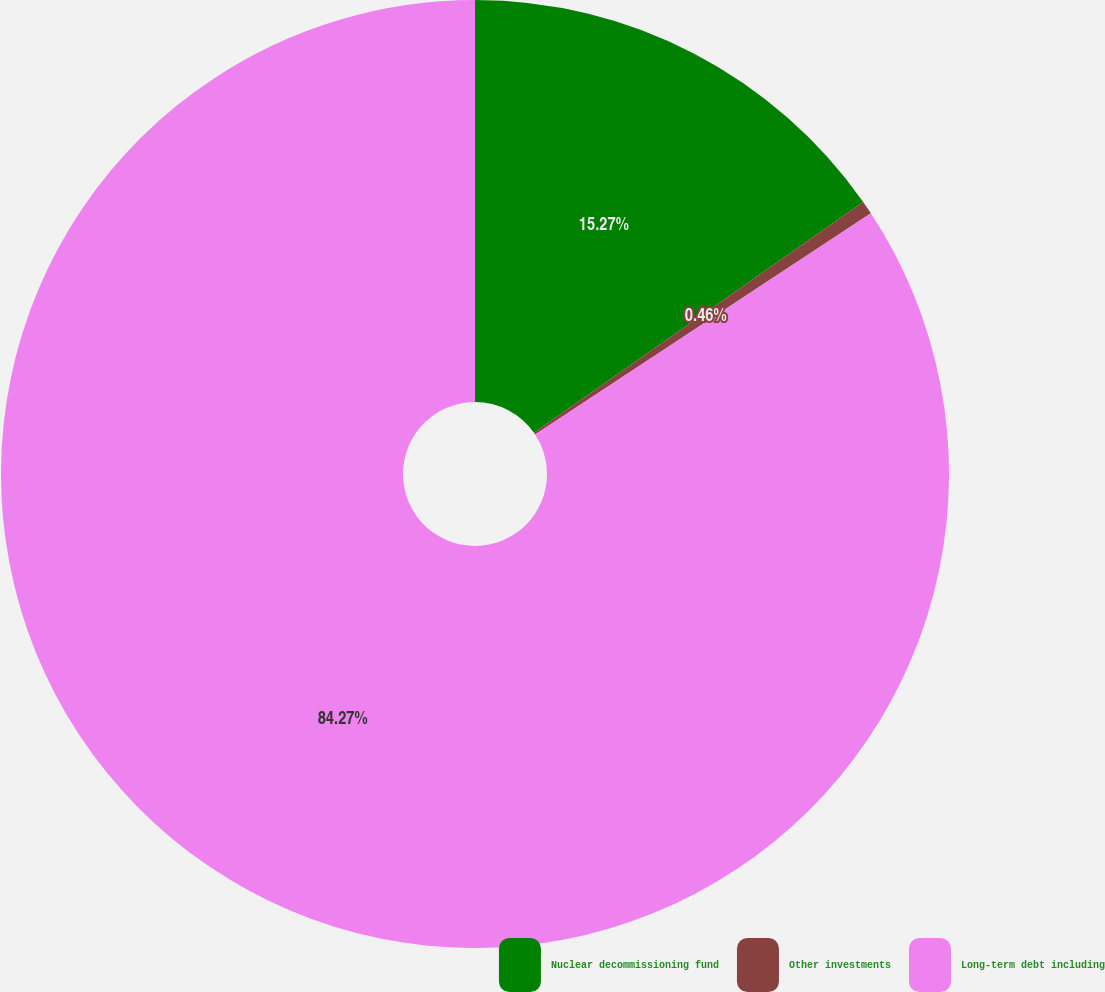Convert chart. <chart><loc_0><loc_0><loc_500><loc_500><pie_chart><fcel>Nuclear decommissioning fund<fcel>Other investments<fcel>Long-term debt including<nl><fcel>15.27%<fcel>0.46%<fcel>84.26%<nl></chart> 